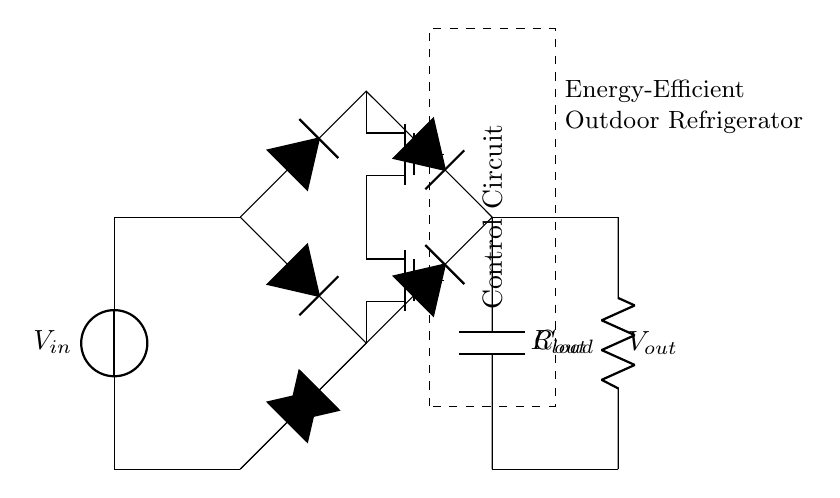What type of rectifier is used in this circuit? The circuit features a synchronous rectifier, characterized by using MOSFETs instead of traditional diodes to improve efficiency.
Answer: synchronous What is the role of the transformer in the circuit? The transformer steps up or steps down the input voltage before it reaches the rectifier stage, facilitating efficient voltage matching.
Answer: voltage matching How many MOSFETs are present in the synchronous rectifier? There are two MOSFETs, labeled M1 and M2, used for the rectification process instead of conventional diodes.
Answer: two What is the purpose of the control circuit? The control circuit manages the operation of the MOSFETs, ensuring they switch correctly for optimal performance during rectification.
Answer: manage operation What is the output component connected to the circuit? The output component is a capacitor, labeled C_out, that smooths the rectified voltage before delivering it to the load resistor.
Answer: capacitor What is the load connected to the circuit? The load is represented by a resistor, labeled R_load, which signifies the device being powered by the rectified output of the circuit.
Answer: resistor What is the main advantage of using synchronous rectification in this circuit? Synchronous rectification allows for lower power losses compared to traditional diodes, resulting in higher efficiency in energy usage.
Answer: higher efficiency 